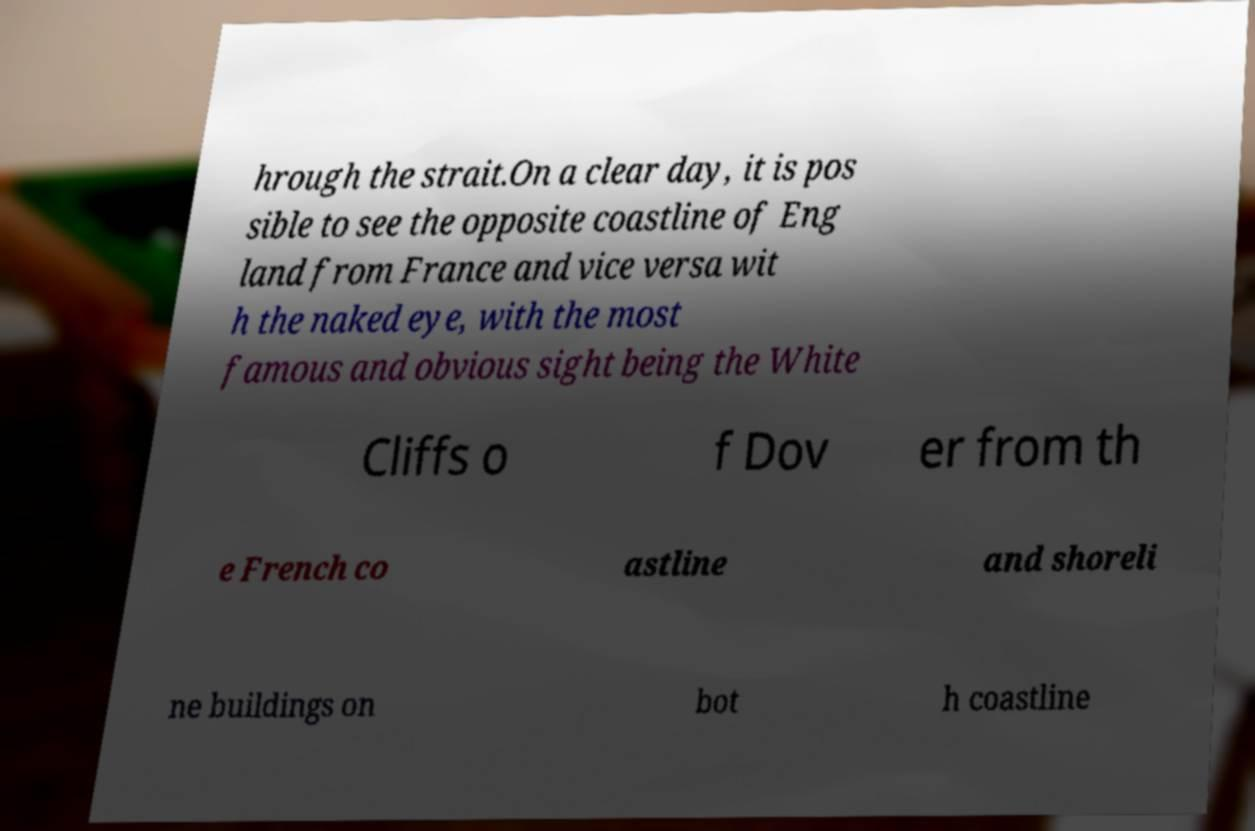Can you accurately transcribe the text from the provided image for me? hrough the strait.On a clear day, it is pos sible to see the opposite coastline of Eng land from France and vice versa wit h the naked eye, with the most famous and obvious sight being the White Cliffs o f Dov er from th e French co astline and shoreli ne buildings on bot h coastline 